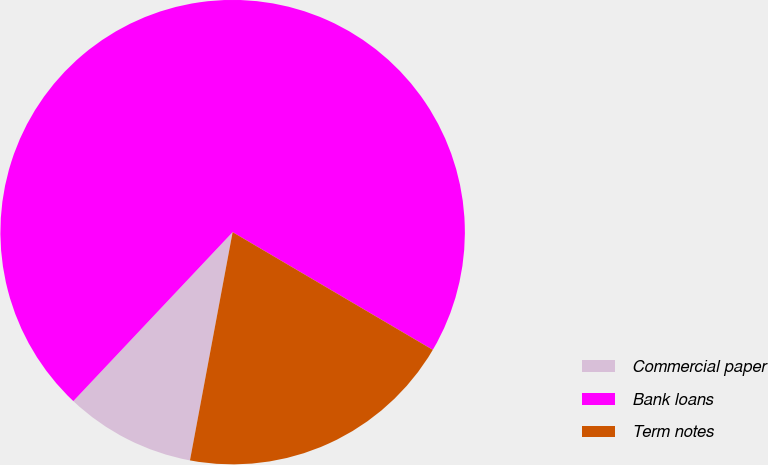Convert chart to OTSL. <chart><loc_0><loc_0><loc_500><loc_500><pie_chart><fcel>Commercial paper<fcel>Bank loans<fcel>Term notes<nl><fcel>9.09%<fcel>71.43%<fcel>19.48%<nl></chart> 